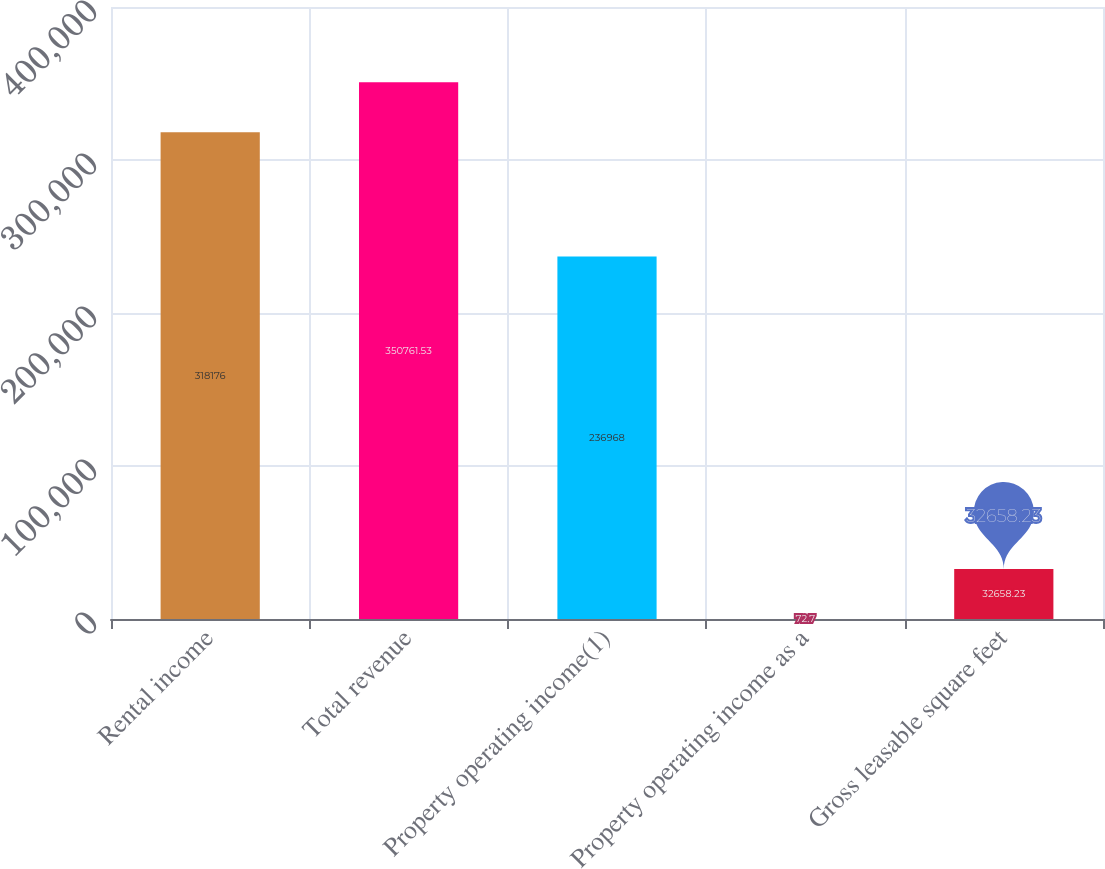Convert chart to OTSL. <chart><loc_0><loc_0><loc_500><loc_500><bar_chart><fcel>Rental income<fcel>Total revenue<fcel>Property operating income(1)<fcel>Property operating income as a<fcel>Gross leasable square feet<nl><fcel>318176<fcel>350762<fcel>236968<fcel>72.7<fcel>32658.2<nl></chart> 